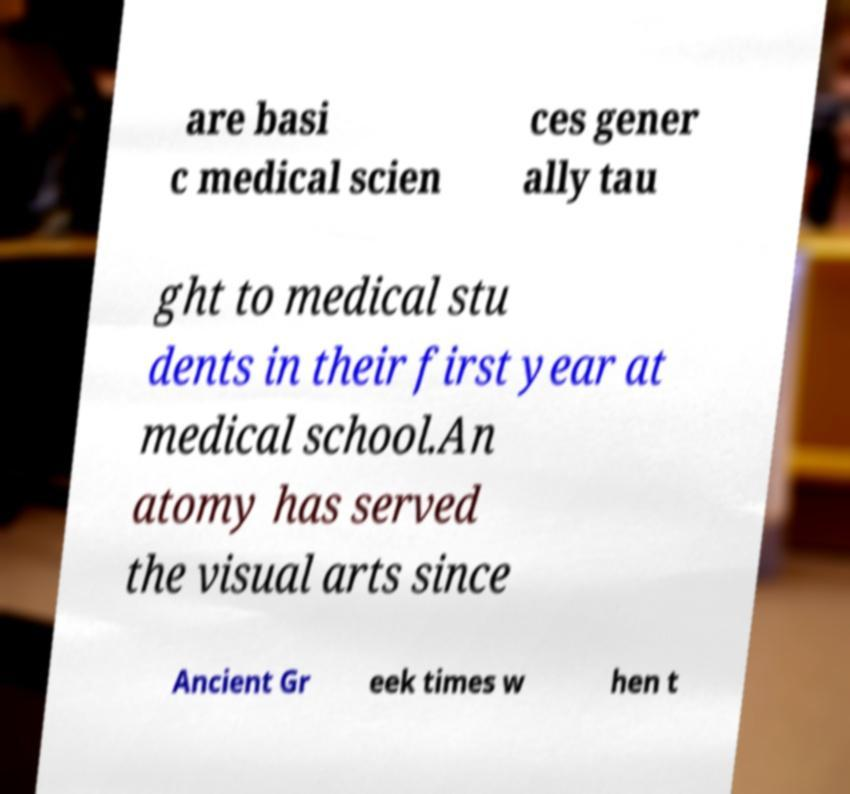For documentation purposes, I need the text within this image transcribed. Could you provide that? are basi c medical scien ces gener ally tau ght to medical stu dents in their first year at medical school.An atomy has served the visual arts since Ancient Gr eek times w hen t 